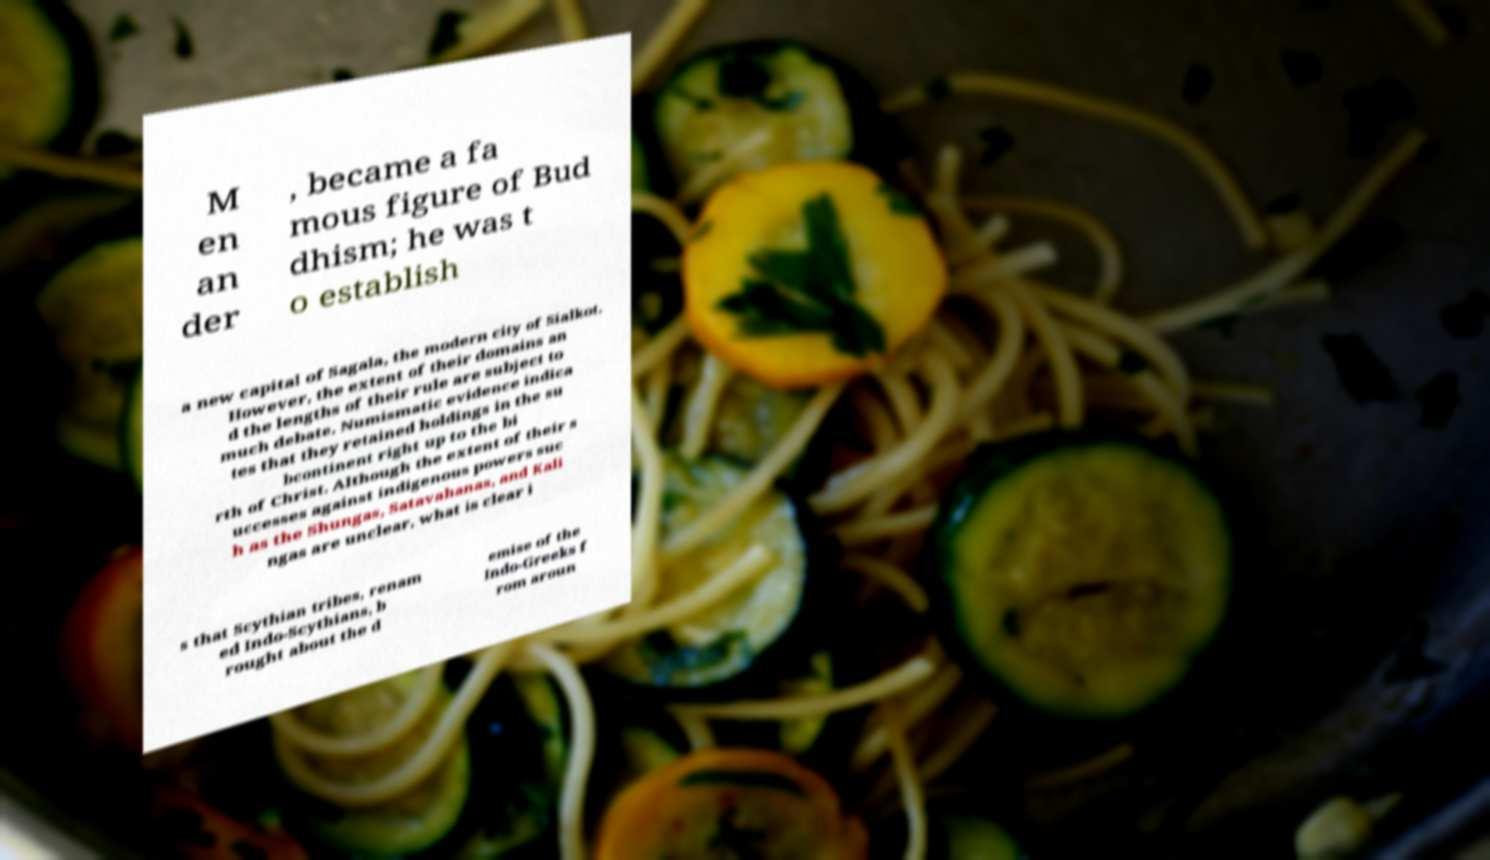There's text embedded in this image that I need extracted. Can you transcribe it verbatim? M en an der , became a fa mous figure of Bud dhism; he was t o establish a new capital of Sagala, the modern city of Sialkot. However, the extent of their domains an d the lengths of their rule are subject to much debate. Numismatic evidence indica tes that they retained holdings in the su bcontinent right up to the bi rth of Christ. Although the extent of their s uccesses against indigenous powers suc h as the Shungas, Satavahanas, and Kali ngas are unclear, what is clear i s that Scythian tribes, renam ed Indo-Scythians, b rought about the d emise of the Indo-Greeks f rom aroun 